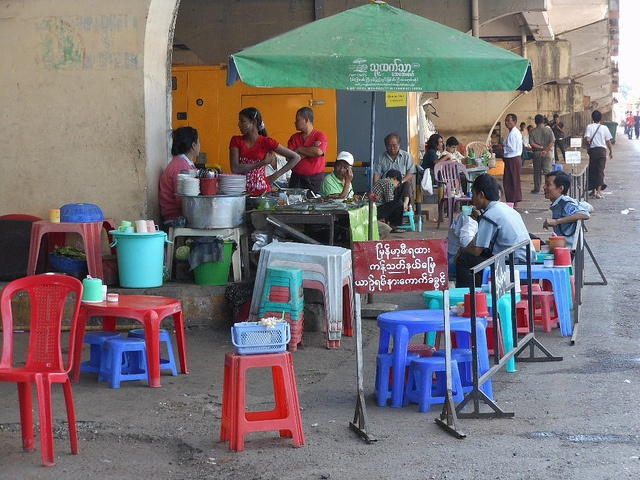Describe the objects in this image and their specific colors. I can see umbrella in gray, teal, and darkgray tones, chair in gray, brown, maroon, and salmon tones, people in gray, darkgray, black, and lavender tones, people in gray, black, and lightblue tones, and dining table in gray, lightblue, blue, and darkblue tones in this image. 